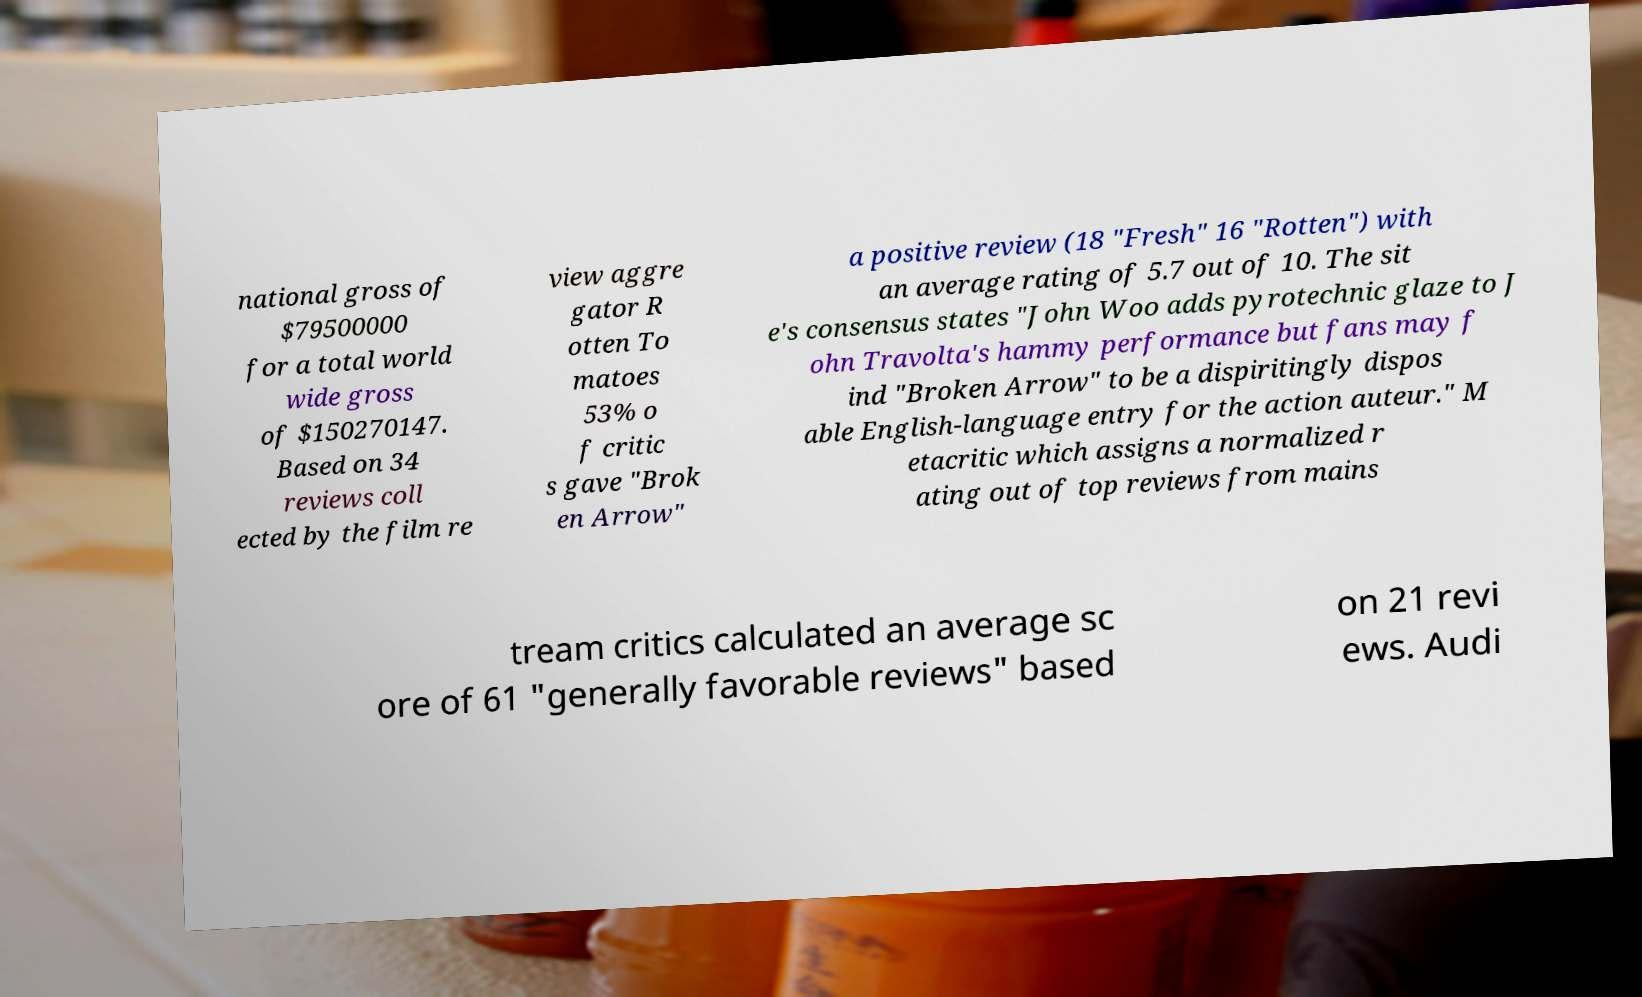Can you read and provide the text displayed in the image?This photo seems to have some interesting text. Can you extract and type it out for me? national gross of $79500000 for a total world wide gross of $150270147. Based on 34 reviews coll ected by the film re view aggre gator R otten To matoes 53% o f critic s gave "Brok en Arrow" a positive review (18 "Fresh" 16 "Rotten") with an average rating of 5.7 out of 10. The sit e's consensus states "John Woo adds pyrotechnic glaze to J ohn Travolta's hammy performance but fans may f ind "Broken Arrow" to be a dispiritingly dispos able English-language entry for the action auteur." M etacritic which assigns a normalized r ating out of top reviews from mains tream critics calculated an average sc ore of 61 "generally favorable reviews" based on 21 revi ews. Audi 